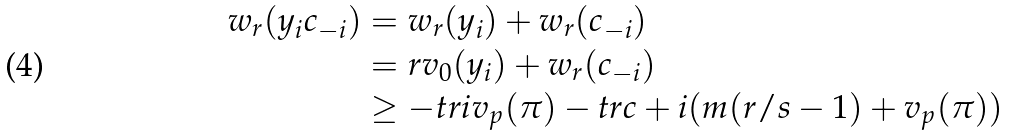<formula> <loc_0><loc_0><loc_500><loc_500>w _ { r } ( y _ { i } c _ { - i } ) & = w _ { r } ( y _ { i } ) + w _ { r } ( c _ { - i } ) \\ & = r v _ { 0 } ( y _ { i } ) + w _ { r } ( c _ { - i } ) \\ & \geq - t r i v _ { p } ( \pi ) - t r c + i ( m ( r / s - 1 ) + v _ { p } ( \pi ) )</formula> 